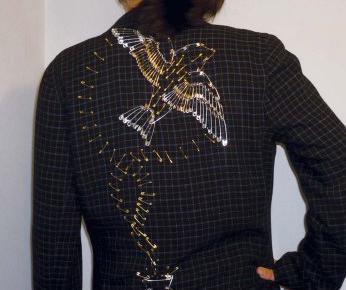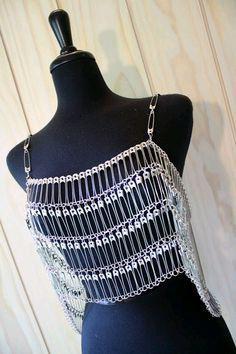The first image is the image on the left, the second image is the image on the right. Examine the images to the left and right. Is the description "There is a black shirt with a peace sign on it and a black collared jacket." accurate? Answer yes or no. No. The first image is the image on the left, the second image is the image on the right. Examine the images to the left and right. Is the description "there is a black top with the peace sihn made from bobby pins" accurate? Answer yes or no. No. 